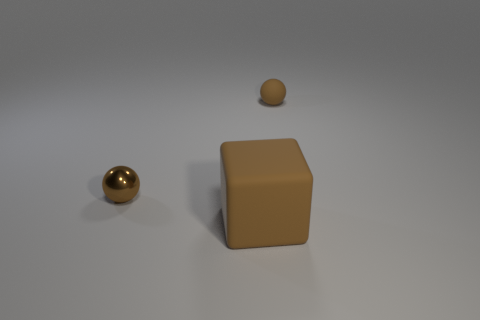Add 2 big green metallic things. How many objects exist? 5 Subtract all cubes. How many objects are left? 2 Add 1 large brown objects. How many large brown objects exist? 2 Subtract 0 red cylinders. How many objects are left? 3 Subtract all small yellow shiny cubes. Subtract all brown metal objects. How many objects are left? 2 Add 2 big brown rubber objects. How many big brown rubber objects are left? 3 